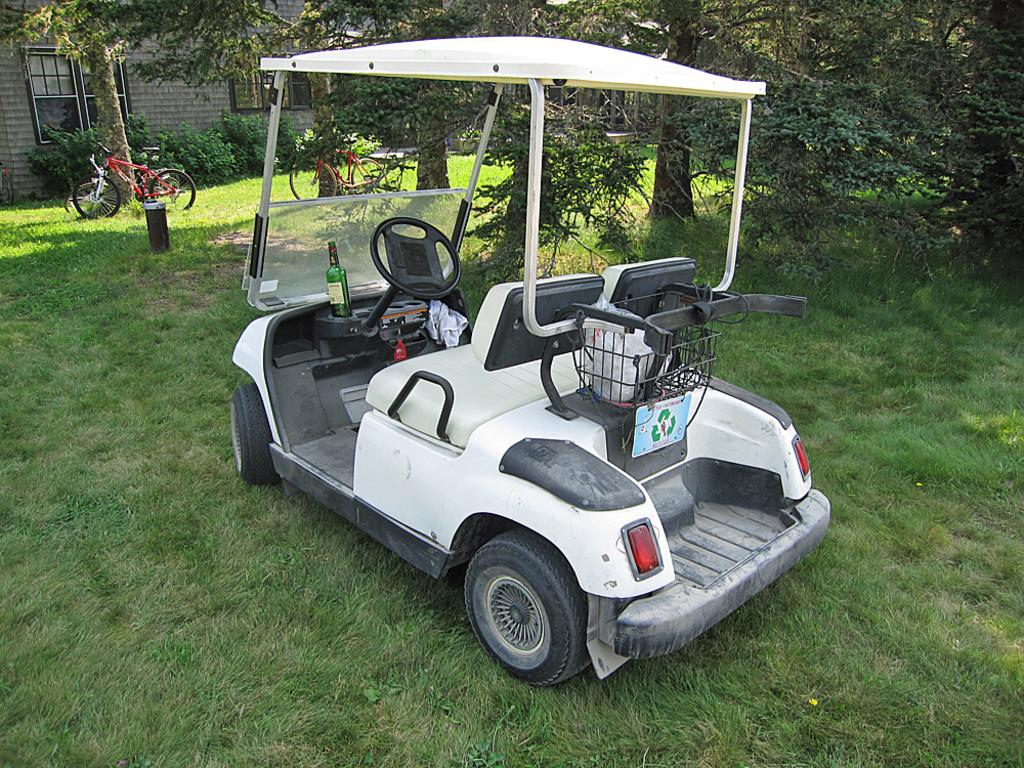What type of vehicles can be seen on the grass in the image? There are vehicles on the grass in the image, but the specific type of vehicles cannot be determined from the provided facts. What other elements are present in the image besides the vehicles? There are plants and trees in the image. Can you describe the setting of the image? The image appears to depict a house, as indicated by the presence of a grassy area and trees. What type of paste is being used to create the science of existence in the image? There is no reference to paste, science, or existence in the image. The image depicts vehicles on the grass, plants, trees, and a house. 